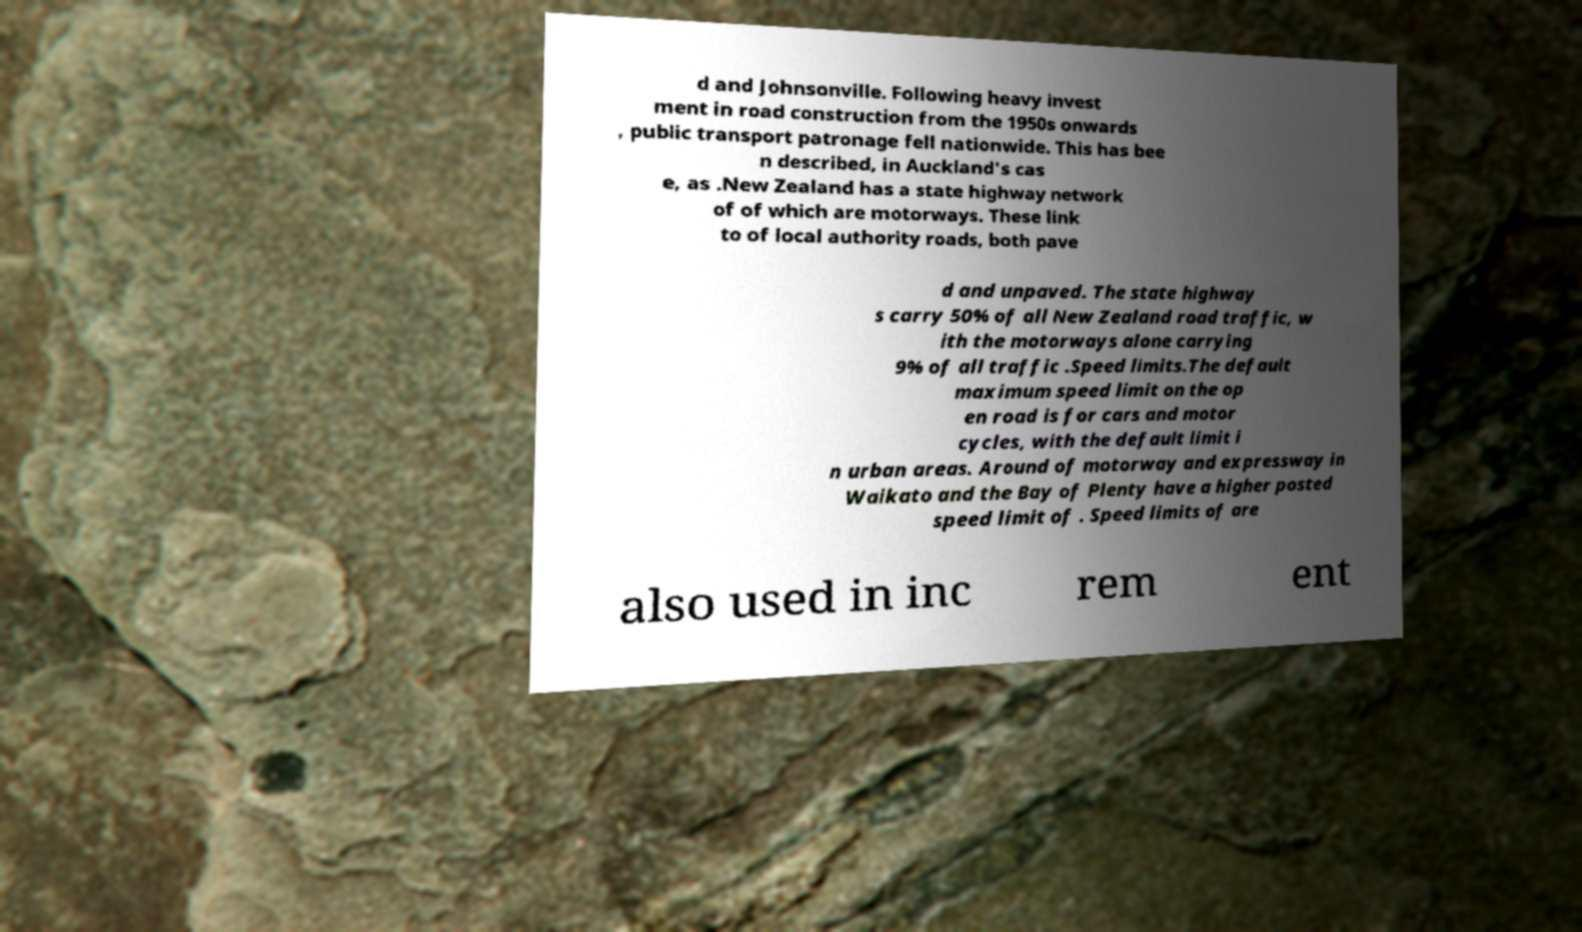Could you assist in decoding the text presented in this image and type it out clearly? d and Johnsonville. Following heavy invest ment in road construction from the 1950s onwards , public transport patronage fell nationwide. This has bee n described, in Auckland's cas e, as .New Zealand has a state highway network of of which are motorways. These link to of local authority roads, both pave d and unpaved. The state highway s carry 50% of all New Zealand road traffic, w ith the motorways alone carrying 9% of all traffic .Speed limits.The default maximum speed limit on the op en road is for cars and motor cycles, with the default limit i n urban areas. Around of motorway and expressway in Waikato and the Bay of Plenty have a higher posted speed limit of . Speed limits of are also used in inc rem ent 